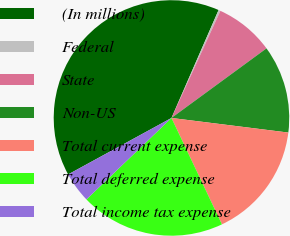Convert chart. <chart><loc_0><loc_0><loc_500><loc_500><pie_chart><fcel>(In millions)<fcel>Federal<fcel>State<fcel>Non-US<fcel>Total current expense<fcel>Total deferred expense<fcel>Total income tax expense<nl><fcel>39.51%<fcel>0.27%<fcel>8.12%<fcel>12.04%<fcel>15.97%<fcel>19.89%<fcel>4.2%<nl></chart> 